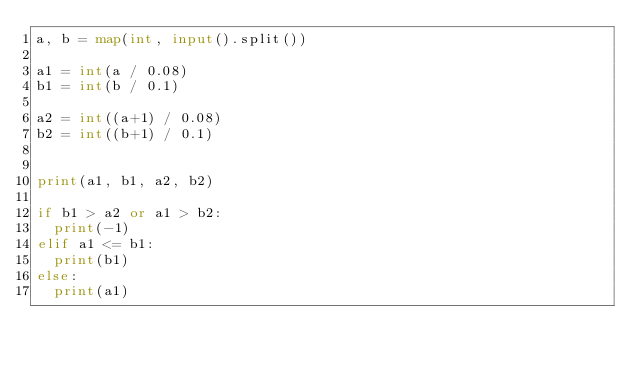Convert code to text. <code><loc_0><loc_0><loc_500><loc_500><_Python_>a, b = map(int, input().split())

a1 = int(a / 0.08)
b1 = int(b / 0.1)

a2 = int((a+1) / 0.08)
b2 = int((b+1) / 0.1)

    
print(a1, b1, a2, b2)

if b1 > a2 or a1 > b2:
  print(-1)
elif a1 <= b1:
  print(b1)
else:
  print(a1)</code> 